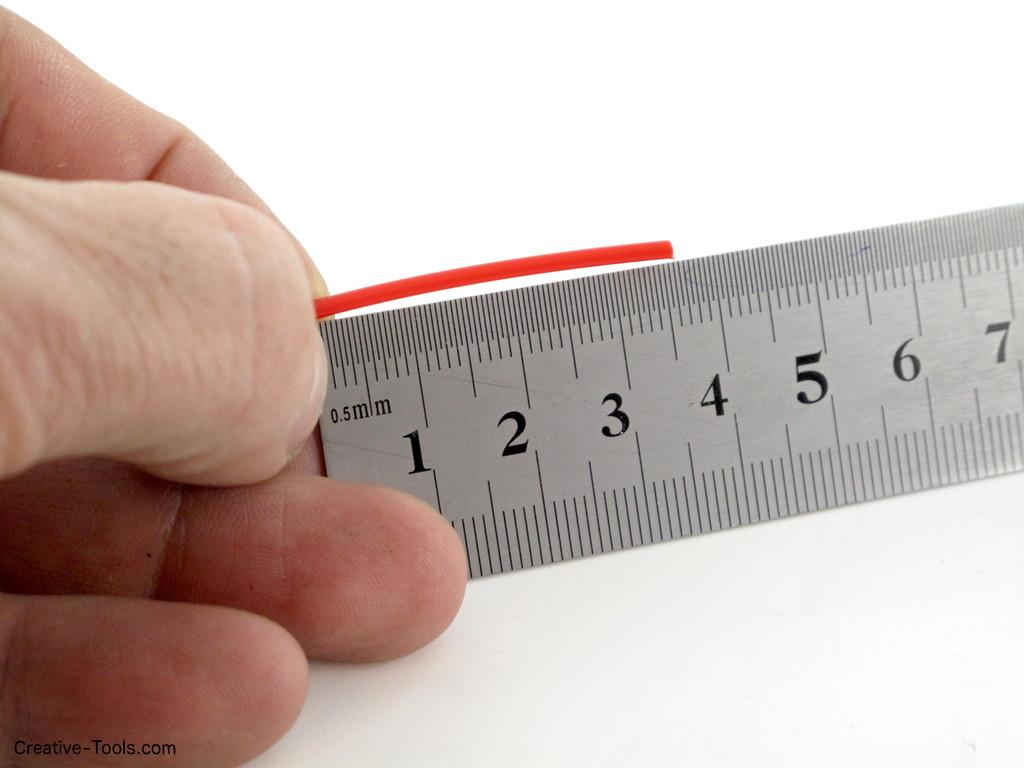<image>
Summarize the visual content of the image. A hand measures a stick on a ruler that shows 7 millimeters. 